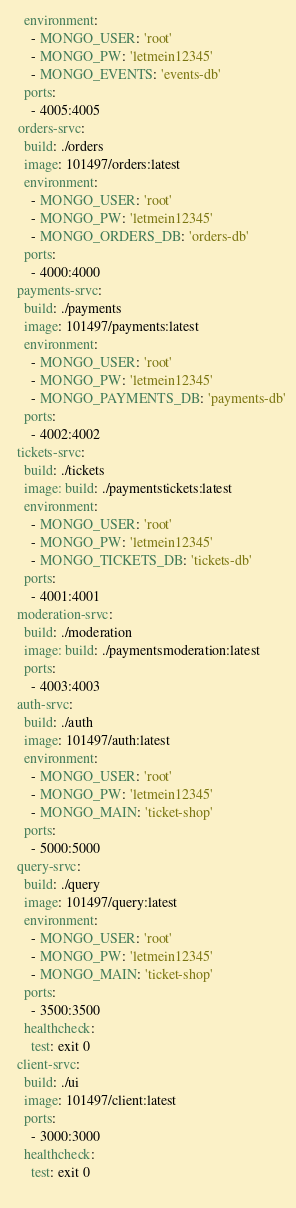Convert code to text. <code><loc_0><loc_0><loc_500><loc_500><_YAML_>    environment:
      - MONGO_USER: 'root'
      - MONGO_PW: 'letmein12345'
      - MONGO_EVENTS: 'events-db'
    ports:
      - 4005:4005
  orders-srvc:
    build: ./orders
    image: 101497/orders:latest
    environment:
      - MONGO_USER: 'root'
      - MONGO_PW: 'letmein12345'
      - MONGO_ORDERS_DB: 'orders-db'
    ports:
      - 4000:4000
  payments-srvc:
    build: ./payments
    image: 101497/payments:latest
    environment:
      - MONGO_USER: 'root'
      - MONGO_PW: 'letmein12345'
      - MONGO_PAYMENTS_DB: 'payments-db'
    ports:
      - 4002:4002
  tickets-srvc:
    build: ./tickets
    image: build: ./paymentstickets:latest
    environment:
      - MONGO_USER: 'root'
      - MONGO_PW: 'letmein12345'
      - MONGO_TICKETS_DB: 'tickets-db'
    ports:
      - 4001:4001
  moderation-srvc:
    build: ./moderation
    image: build: ./paymentsmoderation:latest
    ports:
      - 4003:4003
  auth-srvc:
    build: ./auth
    image: 101497/auth:latest
    environment:
      - MONGO_USER: 'root'
      - MONGO_PW: 'letmein12345'
      - MONGO_MAIN: 'ticket-shop'
    ports:
      - 5000:5000
  query-srvc:
    build: ./query
    image: 101497/query:latest
    environment:
      - MONGO_USER: 'root'
      - MONGO_PW: 'letmein12345'
      - MONGO_MAIN: 'ticket-shop'
    ports:
      - 3500:3500
    healthcheck:
      test: exit 0
  client-srvc:
    build: ./ui
    image: 101497/client:latest
    ports:
      - 3000:3000
    healthcheck:
      test: exit 0
  </code> 